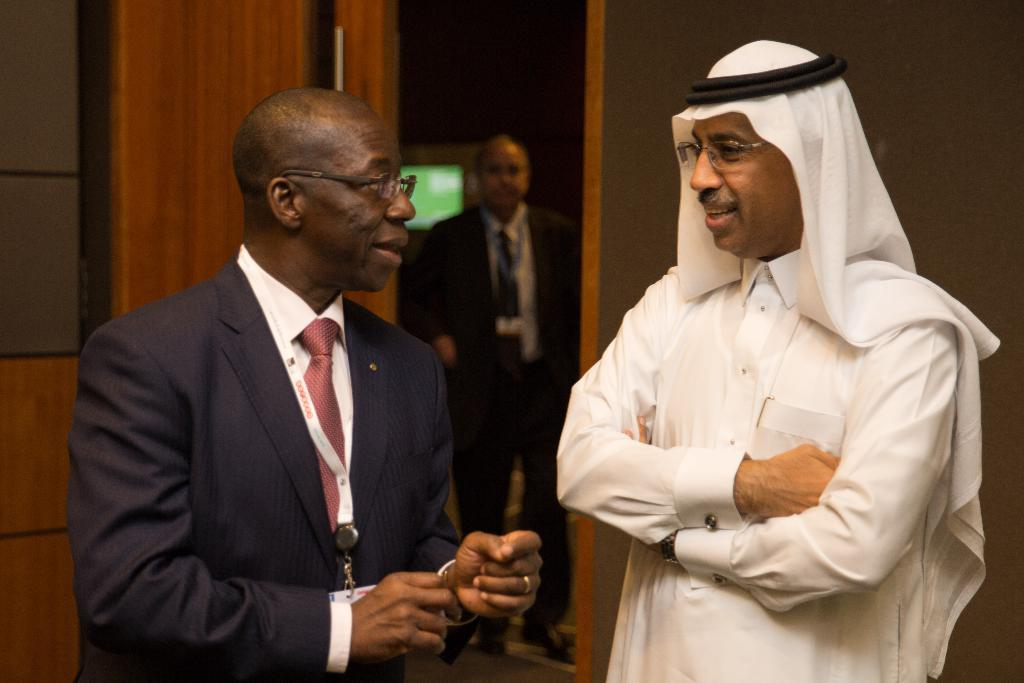How many people are present in the image? There are two people in the image. What can be observed about the people's appearance? Both people are wearing spectacles. Can you describe the setting of the image? There is a person in the background of the image, and there are objects visible in the background. What type of music is being played by the person holding the rifle in the image? There is no person holding a rifle or playing music in the image. 